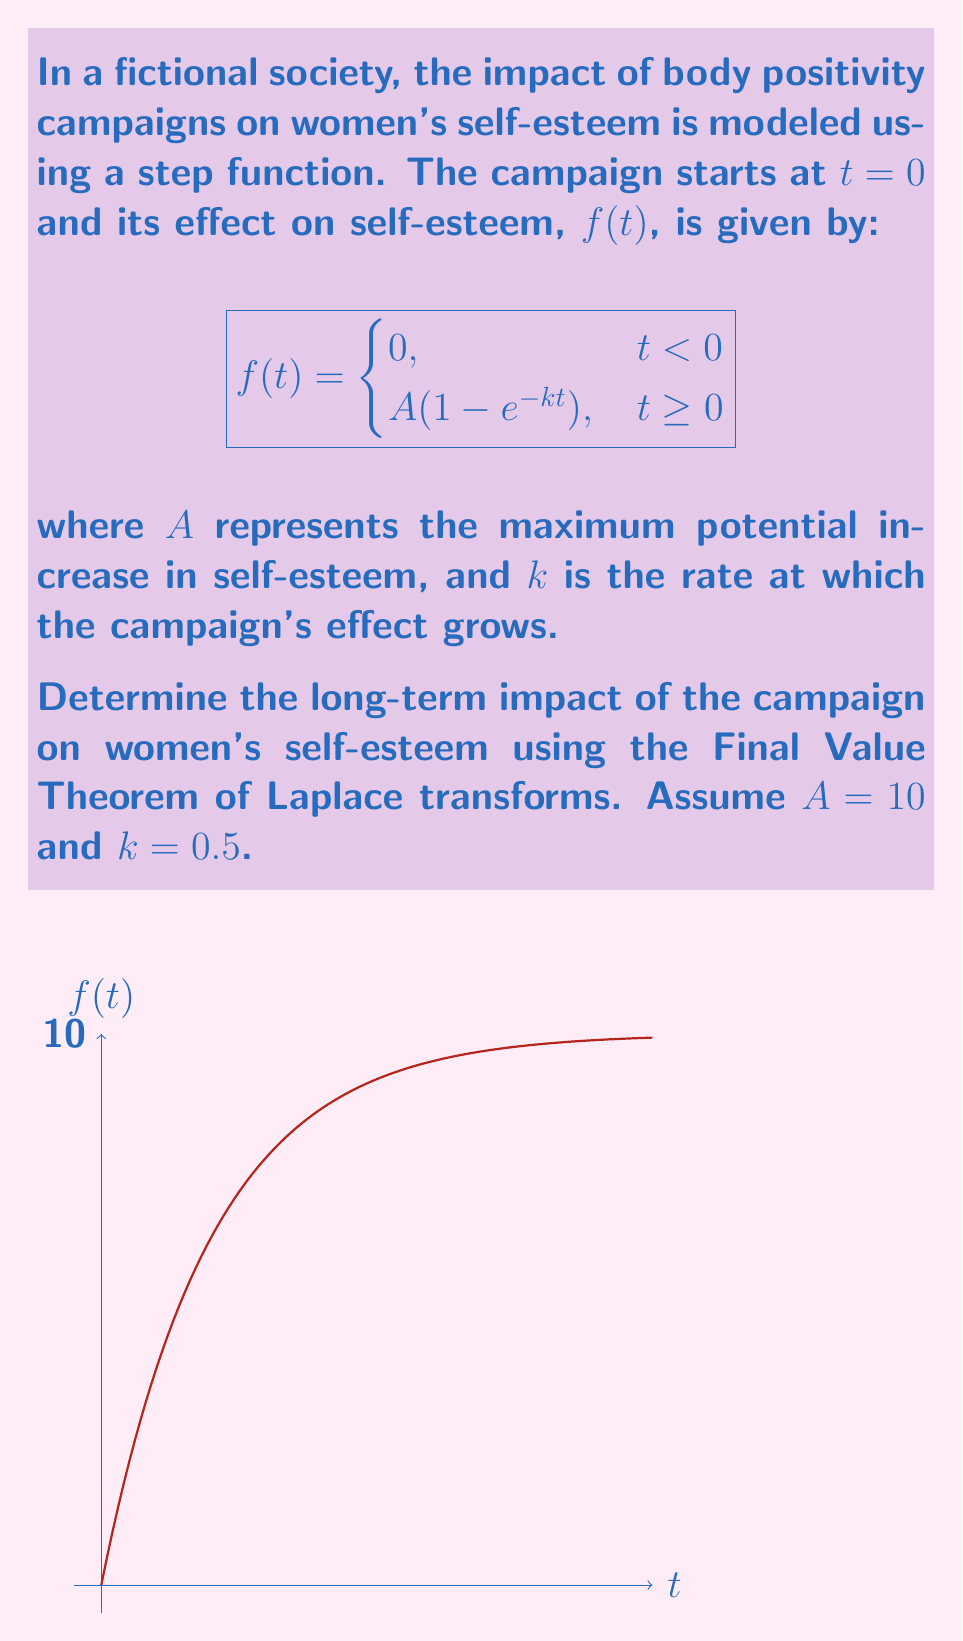Provide a solution to this math problem. To solve this problem, we'll follow these steps:

1) First, we need to find the Laplace transform of f(t). The Laplace transform of a step function multiplied by (1 - e^(-kt)) is:

   $$F(s) = \frac{A}{s} - \frac{A}{s+k}$$

2) Substituting the given values A = 10 and k = 0.5:

   $$F(s) = \frac{10}{s} - \frac{10}{s+0.5}$$

3) The Final Value Theorem states that for a stable system:

   $$\lim_{t \to \infty} f(t) = \lim_{s \to 0} sF(s)$$

4) Let's apply this theorem:

   $$\lim_{s \to 0} s(\frac{10}{s} - \frac{10}{s+0.5})$$

5) Simplify:

   $$\lim_{s \to 0} (10 - \frac{10s}{s+0.5})$$

6) As s approaches 0, the fraction approaches 0:

   $$\lim_{s \to 0} (10 - 0) = 10$$

Therefore, the long-term impact of the campaign on women's self-esteem is an increase of 10 units.
Answer: 10 